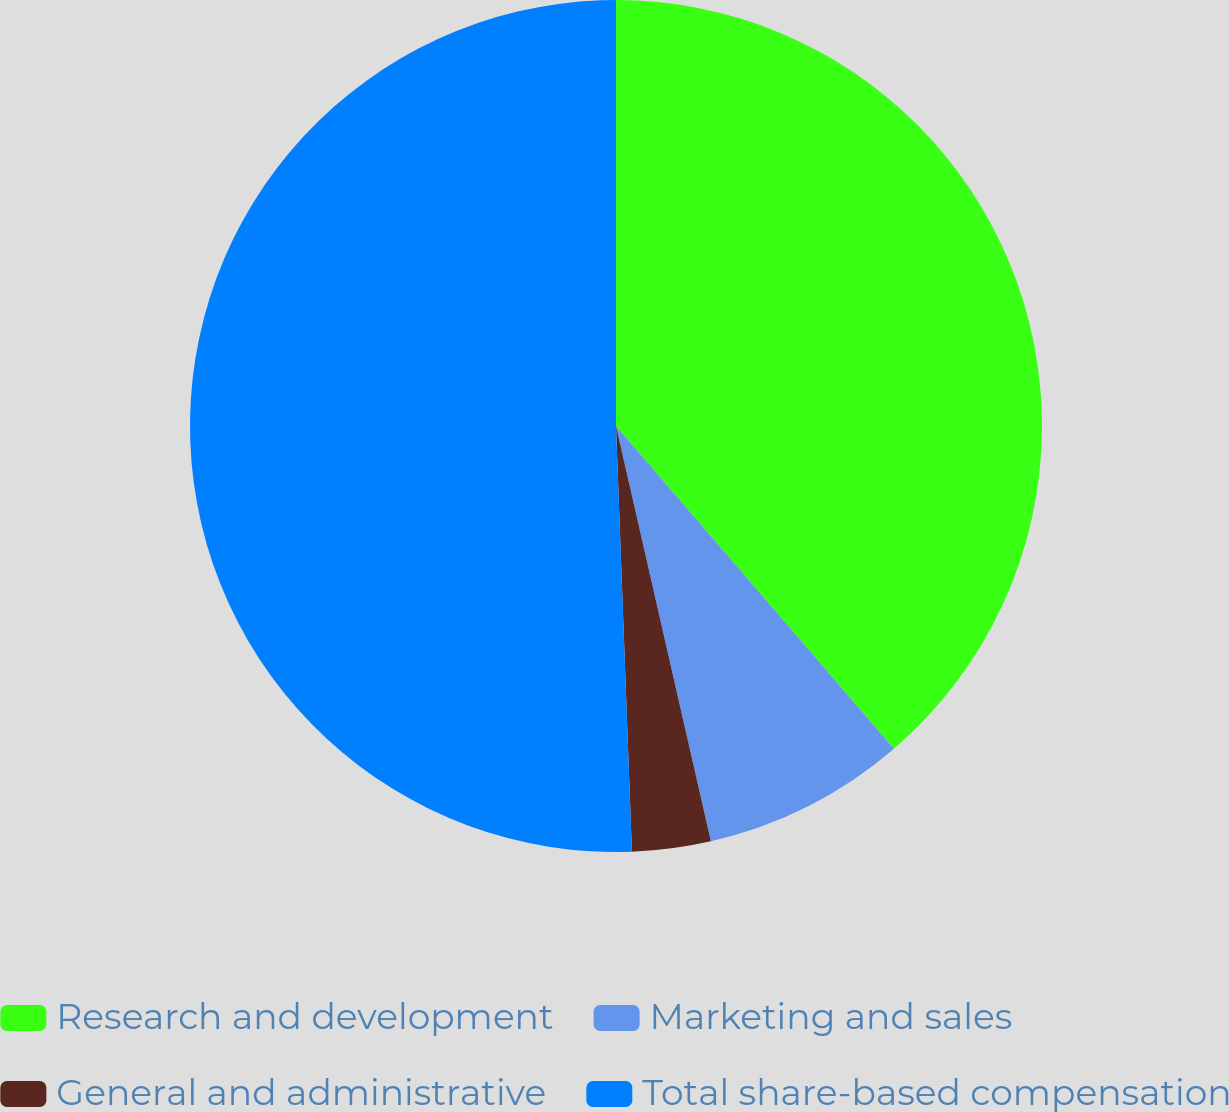Convert chart to OTSL. <chart><loc_0><loc_0><loc_500><loc_500><pie_chart><fcel>Research and development<fcel>Marketing and sales<fcel>General and administrative<fcel>Total share-based compensation<nl><fcel>38.69%<fcel>7.74%<fcel>2.98%<fcel>50.6%<nl></chart> 